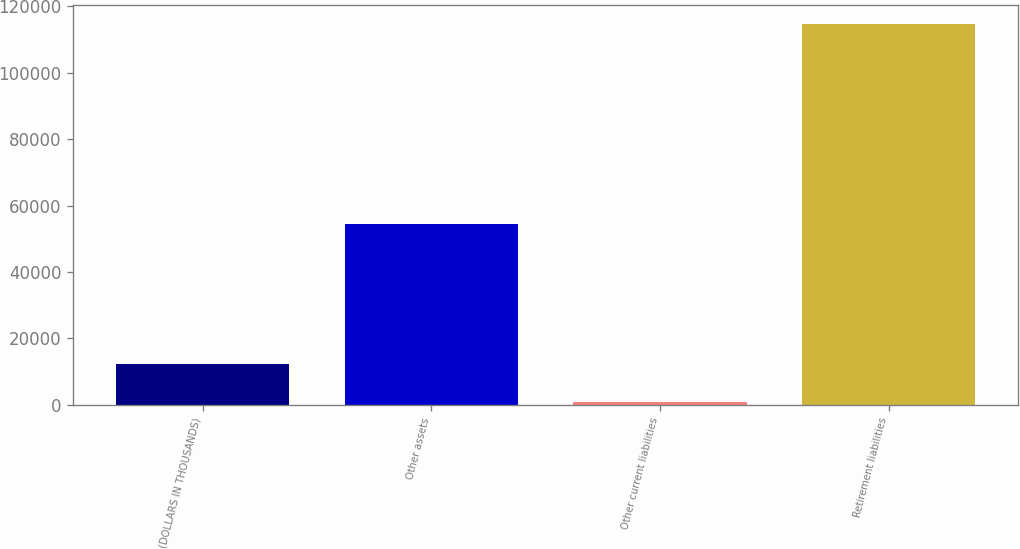Convert chart to OTSL. <chart><loc_0><loc_0><loc_500><loc_500><bar_chart><fcel>(DOLLARS IN THOUSANDS)<fcel>Other assets<fcel>Other current liabilities<fcel>Retirement liabilities<nl><fcel>12264.3<fcel>54434<fcel>882<fcel>114705<nl></chart> 